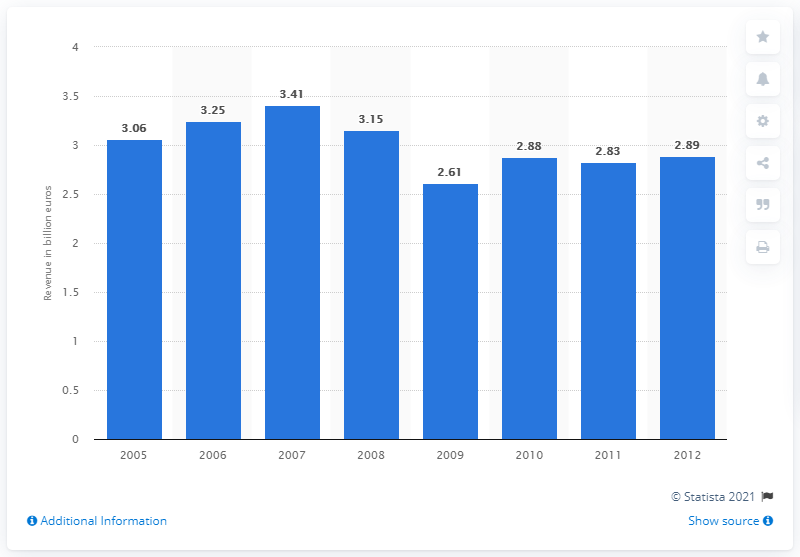Point out several critical features in this image. In 2010, Indesit's revenue was 2.89 billion. 